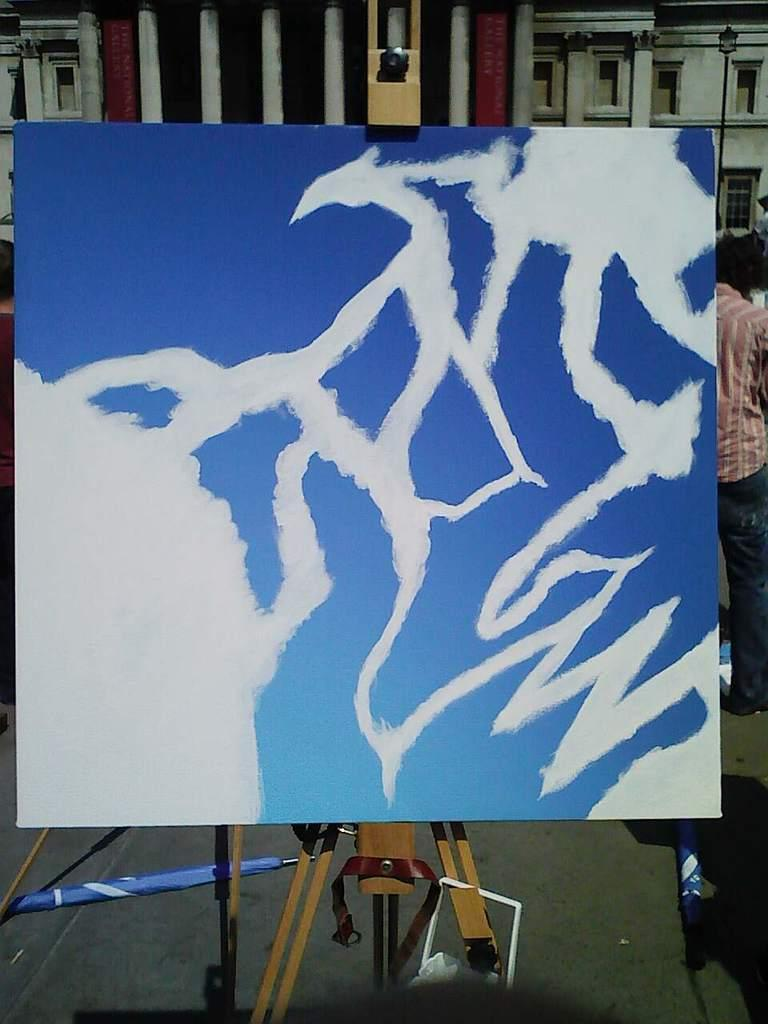What is the main subject of the image? The main subject of the image is a board with a painting. How is the board positioned in the image? The board is on a stand. Can you describe the setting of the image? There is a person visible in the background of the image, and there is a building with windows in the image. What type of toothbrush is the person using in the image? There is no toothbrush present in the image. How many trucks can be seen parked near the building in the image? There are no trucks visible in the image. 